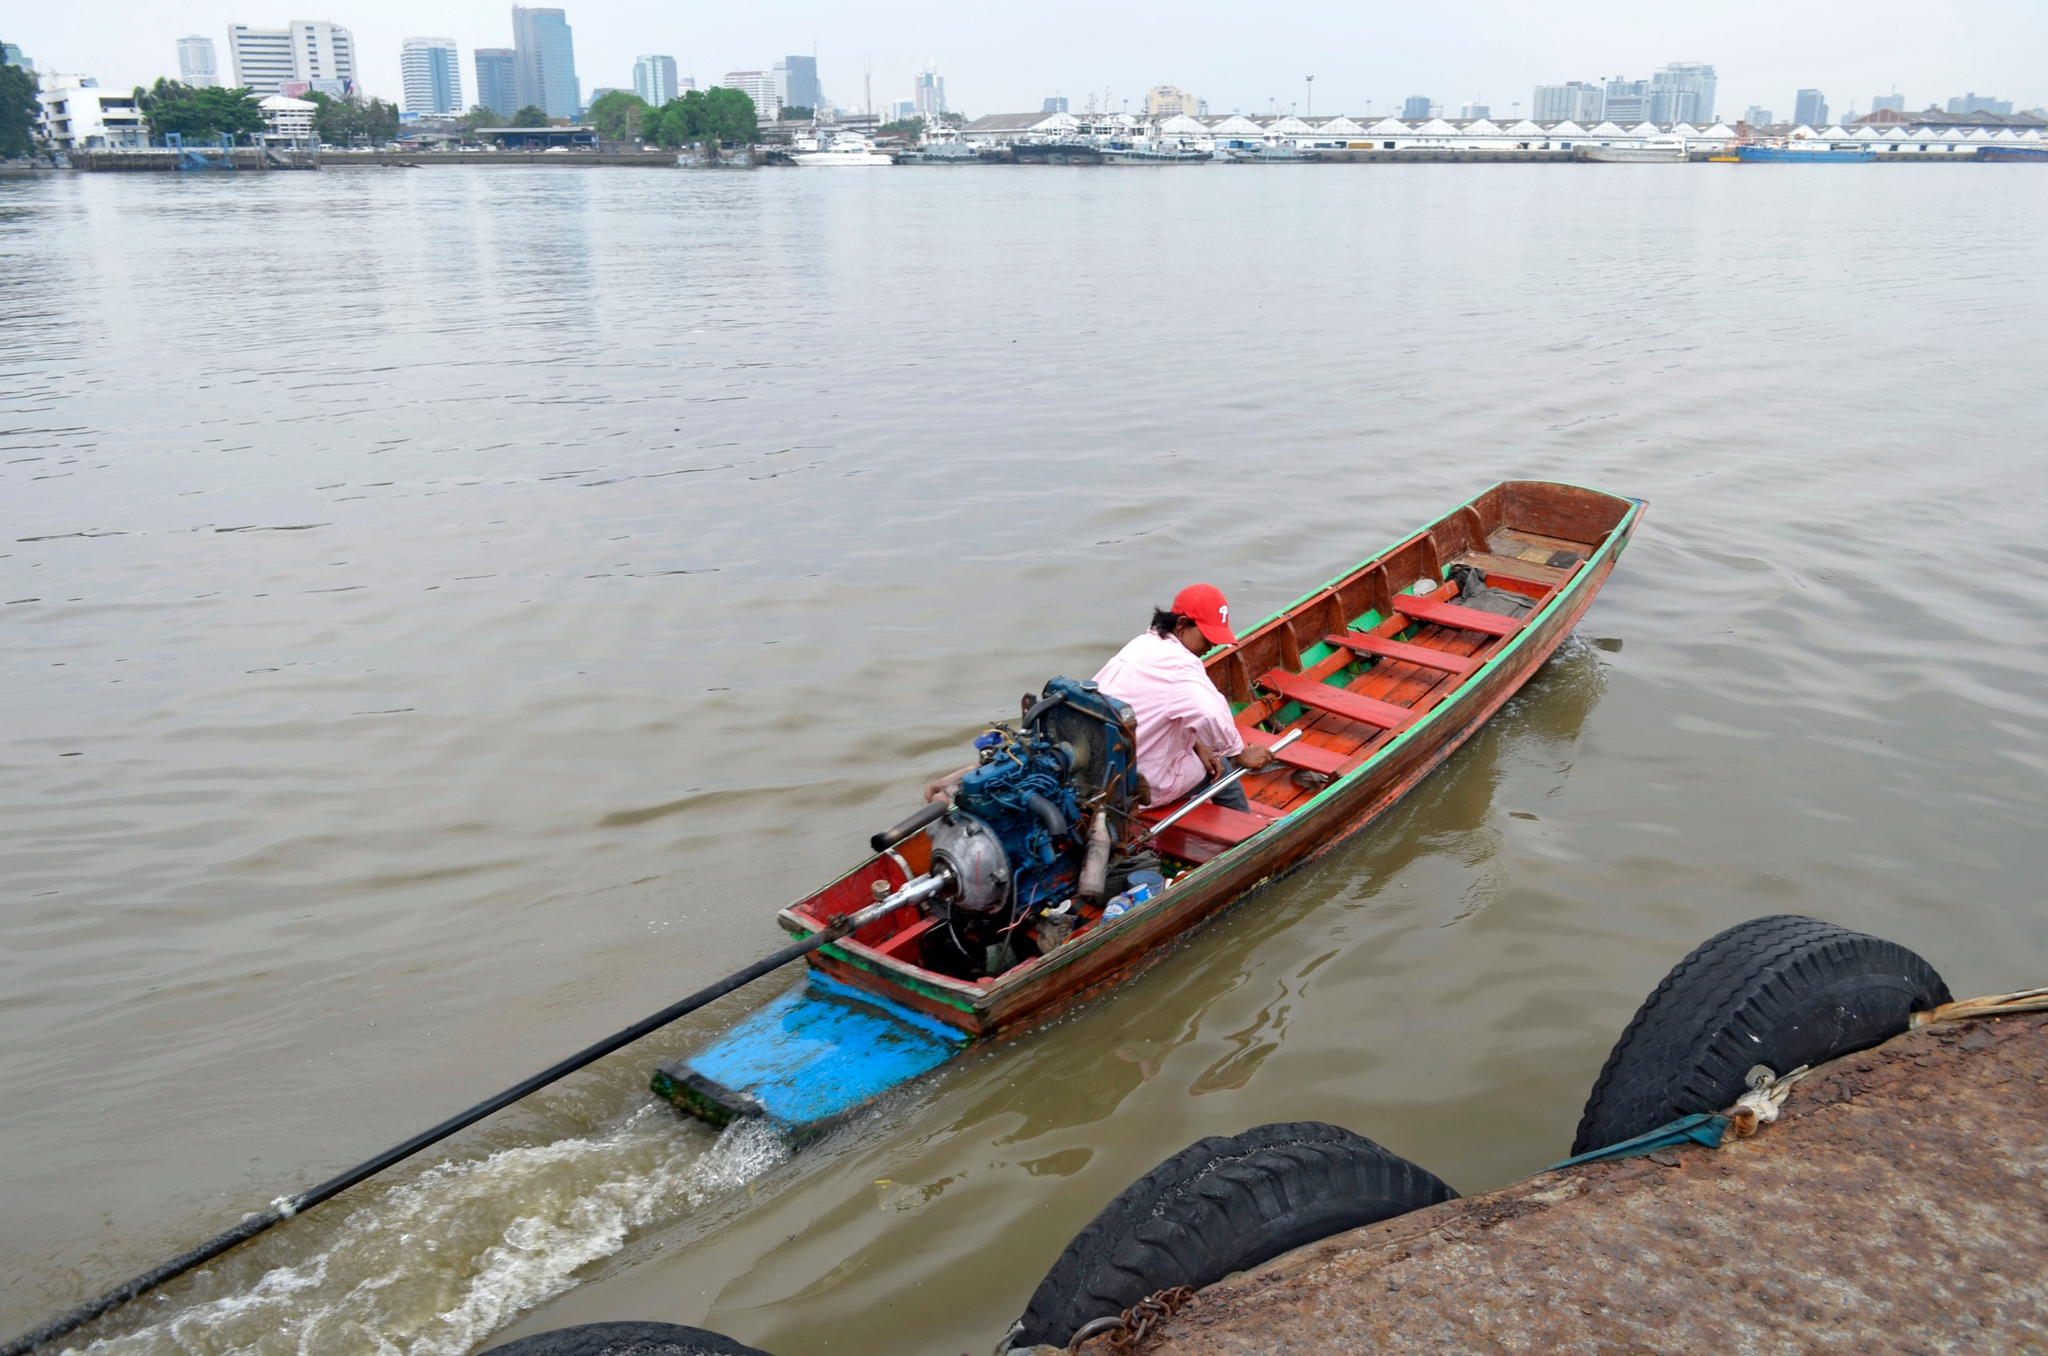Suppose the boat ride is part of a daily routine for the individual. What might their typical day look like? Suppose the boat ride is part of the individual's daily routine. Their typical day might start early in the morning, with the person waking up at dawn. After a quick breakfast, they head toward the river to prepare their boat. Navigating the calm morning waters, they might stop by different points along the river, perhaps delivering goods, picking up supplies, or transporting passengers.

By midday, they might take a break, finding a quiet spot along the riverbank to have lunch and relax. The afternoon could be spent continuing their journey or completing tasks related to their river duties. As the day winds down, they return to their starting point, making sure the boat is secure and ready for the next day.

Evenings might be spent enjoying the natural beauty of the river, perhaps fishing or simply relaxing by the water’s edge. This routine combines both work and moments of tranquility, with the river playing a central role in the rhythm of their daily life. 